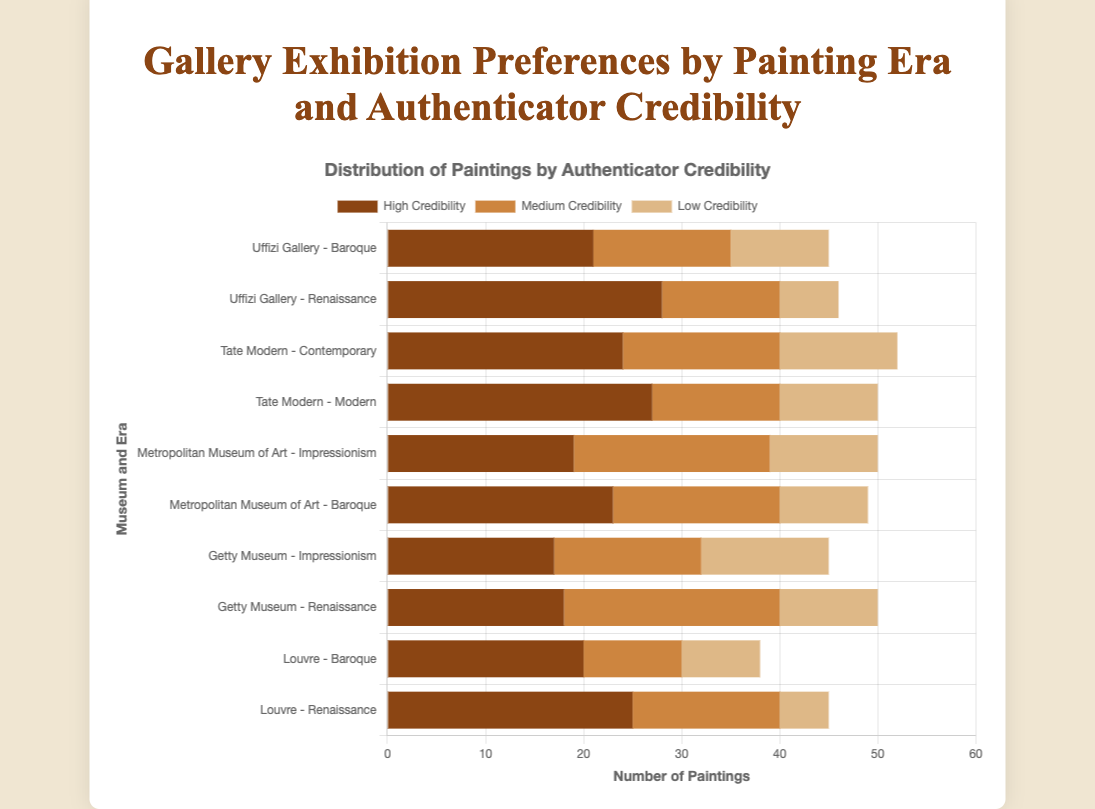What's the total number of paintings with high credibility at the Louvre? Sum the values for "High Credibility" at the Louvre for Renaissance (25) and Baroque (20) eras. 25 + 20 = 45
Answer: 45 Which museum has the highest number of Renaissance paintings with high credibility? Compare the "High Credibility" values for the Renaissance era across museums: Louvre (25), Getty Museum (18), Uffizi Gallery (28). 28 is the highest value, so Uffizi Gallery has the highest number.
Answer: Uffizi Gallery What is the difference in the number of Impressionism paintings with high credibility between the Getty Museum and the Metropolitan Museum of Art? Compare the "High Credibility" values for Impressionism at the two museums: Getty Museum (17) and Metropolitan Museum of Art (19). Calculate the difference: 19 - 17 = 2
Answer: 2 What is the sum of paintings with medium credibility at the Tate Modern across both eras? Sum the "Medium Credibility" values for Modern (13) and Contemporary (16) eras at Tate Modern. 13 + 16 = 29
Answer: 29 Which museum has the lowest number of paintings with low credibility for the Renaissance era? Compare the "Low Credibility" values for the Renaissance era across museums: Louvre (5), Getty Museum (10), Uffizi Gallery (6). The lowest value is 5, so Louvre has the lowest number.
Answer: Louvre How many more paintings with high credibility does the Uffizi Gallery have compared to the Tate Modern in their respective highest era? The highest "High Credibility" value for Uffizi Gallery is 28 (Renaissance) and for Tate Modern is 27 (Modern). Calculate the difference: 28 - 27 = 1
Answer: 1 What’s the total number of paintings exhibited at the Metropolitan Museum of Art? Sum the values for all credibility levels across both eras (Impressionism and Baroque) at the Metropolitan Museum of Art. High Credibility: 19 (Impressionism) + 23 (Baroque) = 42, Medium Credibility: 20 (Impressionism) + 17 (Baroque) = 37, Low Credibility: 11 (Impressionism) + 9 (Baroque) = 20. Total: 42 + 37 + 20 = 99
Answer: 99 Which museum and era combination has the highest number of paintings with low credibility? Compare the "Low Credibility" values across all museum and era combinations. The highest value is 13 (Getty Museum - Impressionism).
Answer: Getty Museum - Impressionism What is the average number of paintings with medium credibility across all eras and museums? Sum all the "Medium Credibility" values and divide by the number of data points. Total medium credibility values: 15 + 10 + 22 + 15 + 17 + 20 + 13 + 16 + 12 + 14 = 154. Number of data points: 10. Average = 154 / 10 = 15.4
Answer: 15.4 How does the number of Baroque paintings with high credibility at the Metropolitan Museum of Art compare to that of the Louvre? Compare the "High Credibility" values for Baroque era at the two museums: Metropolitan Museum of Art (23) and Louvre (20). 23 is greater than 20.
Answer: Metropolitan Museum of Art has more 